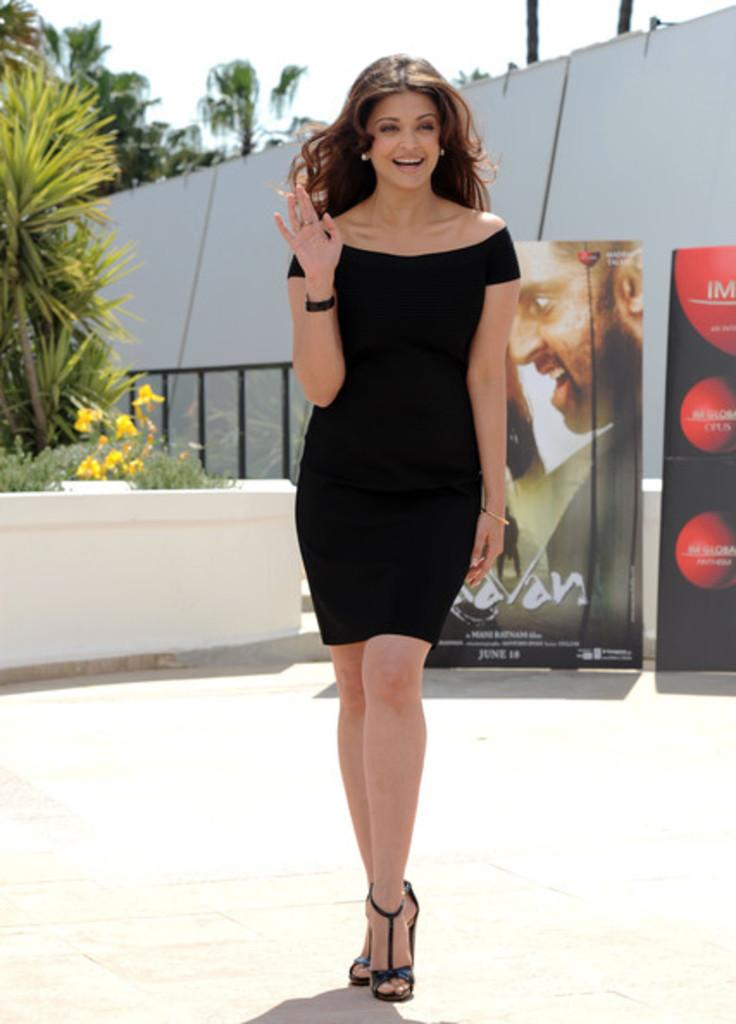What is the main subject of the image? There is a lady standing in the center of the image. What can be seen in the background of the image? There are boards, trees, plants, and a railing in the background of the image. What type of mint is growing on the railing in the image? There is no mint growing on the railing in the image; the provided facts do not mention any mint. 